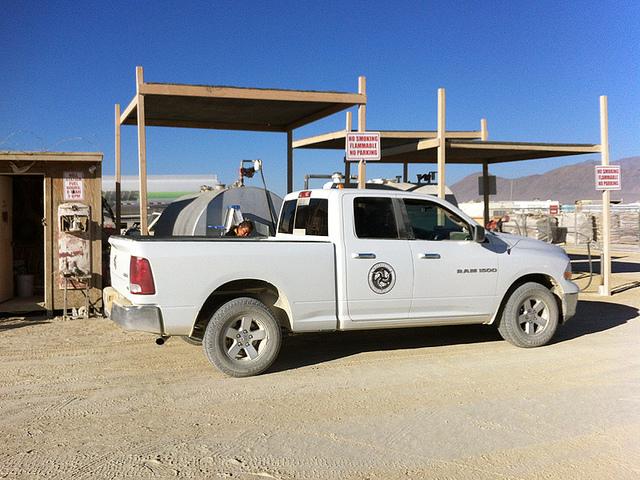Would you like to drive this truck?
Quick response, please. Yes. What is above the vehicle?
Quick response, please. Truck. Is this a new truck?
Short answer required. Yes. Has this car been detailed?
Write a very short answer. No. Is this picture in color?
Keep it brief. Yes. Is this an exhibition?
Answer briefly. No. Is there any signage to indicate what is in the truck?
Write a very short answer. Yes. Where is a silver ladder?
Be succinct. Behind truck. Is the vehicle full?
Write a very short answer. No. Is this a military vehicle?
Give a very brief answer. No. Are the people in the truck traveling?
Write a very short answer. No. Does this photo have toys in it?
Short answer required. No. What color is the vehicle?
Give a very brief answer. White. Is the vehicle refilling?
Quick response, please. Yes. What year is this truck from?
Short answer required. 2012. Is this truck noisy?
Concise answer only. No. How many double cab trucks can be seen?
Give a very brief answer. 1. How many cars in this picture?
Quick response, please. 1. What color is the truck?
Quick response, please. White. Is there any women sitting on the back of the truck?
Quick response, please. No. 